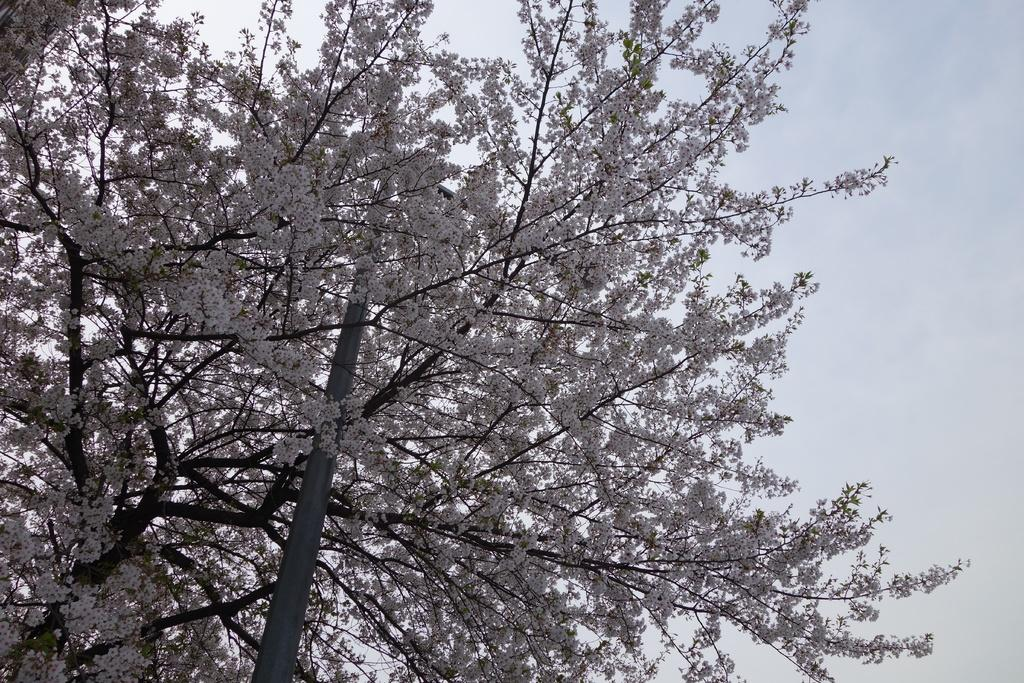What type of plant can be seen in the image? There is a tree in the image. What other object is present in the image? There is a pole in the image. What is visible in the background of the image? The sky is visible in the image. What type of juice can be seen dripping from the tree in the image? There is no juice dripping from the tree in the image. What type of cable is connected to the pole in the image? There is no cable connected to the pole in the image. 